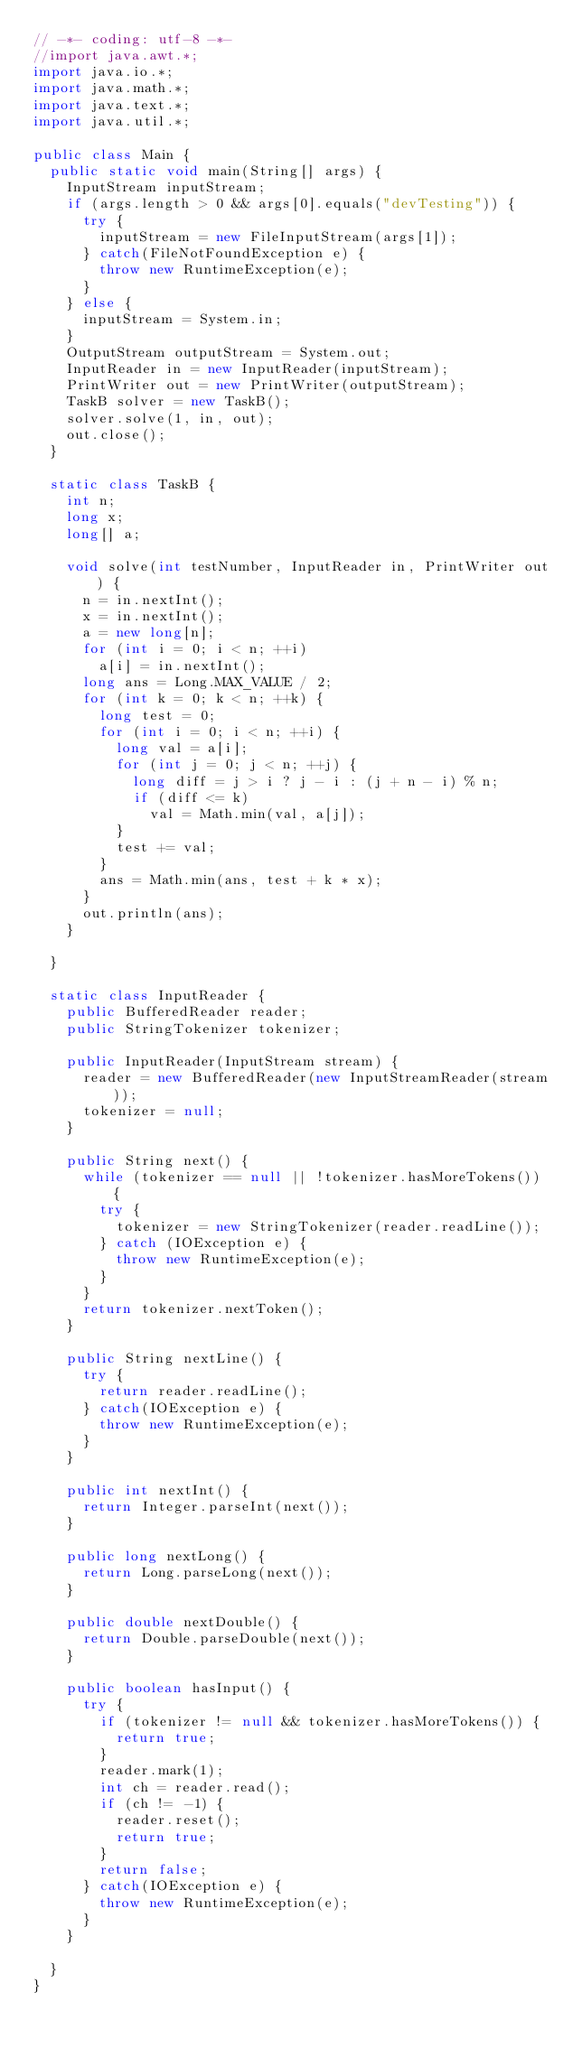Convert code to text. <code><loc_0><loc_0><loc_500><loc_500><_Java_>// -*- coding: utf-8 -*-
//import java.awt.*;
import java.io.*;
import java.math.*;
import java.text.*;
import java.util.*;

public class Main {
  public static void main(String[] args) {
    InputStream inputStream;
    if (args.length > 0 && args[0].equals("devTesting")) {
      try {
        inputStream = new FileInputStream(args[1]);
      } catch(FileNotFoundException e) {
        throw new RuntimeException(e);
      }
    } else {
      inputStream = System.in;
    }
    OutputStream outputStream = System.out;
    InputReader in = new InputReader(inputStream);
    PrintWriter out = new PrintWriter(outputStream);
    TaskB solver = new TaskB();
    solver.solve(1, in, out);
    out.close();
  }
  
  static class TaskB {    
    int n;
    long x;
    long[] a;
    
    void solve(int testNumber, InputReader in, PrintWriter out) {
      n = in.nextInt();
      x = in.nextInt();
      a = new long[n];
      for (int i = 0; i < n; ++i)
        a[i] = in.nextInt();
      long ans = Long.MAX_VALUE / 2;
      for (int k = 0; k < n; ++k) {
        long test = 0;
        for (int i = 0; i < n; ++i) {
          long val = a[i];
          for (int j = 0; j < n; ++j) {
            long diff = j > i ? j - i : (j + n - i) % n;
            if (diff <= k)
              val = Math.min(val, a[j]);
          }
          test += val;
        }
        ans = Math.min(ans, test + k * x);
      }
      out.println(ans);
    }
    
  }
      
  static class InputReader {
    public BufferedReader reader;
    public StringTokenizer tokenizer;

    public InputReader(InputStream stream) {
      reader = new BufferedReader(new InputStreamReader(stream));
      tokenizer = null;
    }

    public String next() {
      while (tokenizer == null || !tokenizer.hasMoreTokens()) {
        try {
          tokenizer = new StringTokenizer(reader.readLine());
        } catch (IOException e) {
          throw new RuntimeException(e);
        }
      }
      return tokenizer.nextToken();
    }
    
    public String nextLine() {
      try {
        return reader.readLine();
      } catch(IOException e) {
        throw new RuntimeException(e);
      }
    }

    public int nextInt() {
      return Integer.parseInt(next());
    }

    public long nextLong() {
      return Long.parseLong(next());
    }
    
    public double nextDouble() {
      return Double.parseDouble(next());
    }

    public boolean hasInput() {
      try {
        if (tokenizer != null && tokenizer.hasMoreTokens()) {
          return true;
        }
        reader.mark(1);
        int ch = reader.read();
        if (ch != -1) {
          reader.reset();
          return true;
        }
        return false;
      } catch(IOException e) {
        throw new RuntimeException(e);
      }
    }
    
  }
}
</code> 